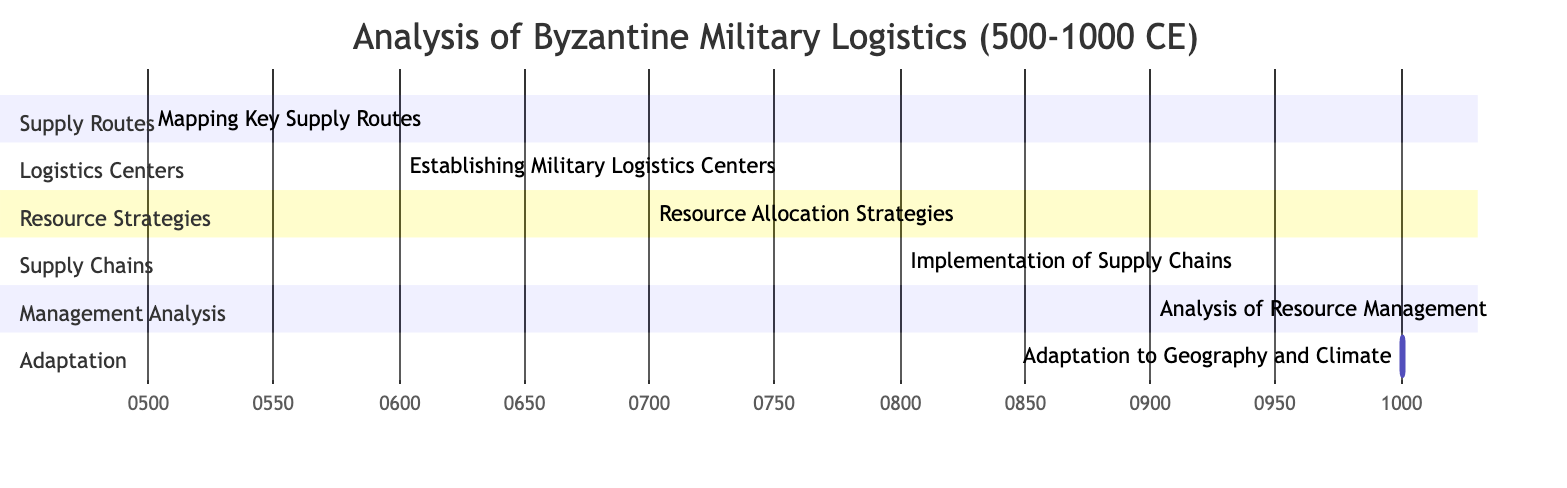What task spans the year 600? The task that spans the year 600 is "Establishing Military Logistics Centers," which has a start date of 600-01-01 and an end date of 600-12-31, clearly within that single year.
Answer: Establishing Military Logistics Centers How many sections are present in the diagram? The diagram has four main sections: Supply Routes, Logistics Centers, Resource Strategies, Supply Chains, Management Analysis, and Adaptation. This totals to six sections.
Answer: 6 Which task comes after the "Implementation of Supply Chains"? After "Implementation of Supply Chains," the next task is "Analysis of Resource Management," which begins immediately in the next century (900-01-01).
Answer: Analysis of Resource Management What is the duration of "Resource Allocation Strategies"? The duration of "Resource Allocation Strategies" is one year, specifically from 700-01-01 to 700-12-31, indicating it takes a full year to complete.
Answer: 1 year What are the years encompassed by the "Adaptation to Geography and Climate" task? The years for the "Adaptation to Geography and Climate" task are from 1000-01-01 to 1000-12-31, indicating it occurs throughout the entire year of 1000.
Answer: 1000 Which task overlaps with the year 900? The task that overlaps with the year 900 is "Analysis of Resource Management," which runs from 900-01-01 to 900-12-31, fully within that year.
Answer: Analysis of Resource Management Which task directly follows "Establishing Military Logistics Centers"? The task that directly follows "Establishing Military Logistics Centers," which ends in the year 600, is "Resource Allocation Strategies," starting in the year 700.
Answer: Resource Allocation Strategies 